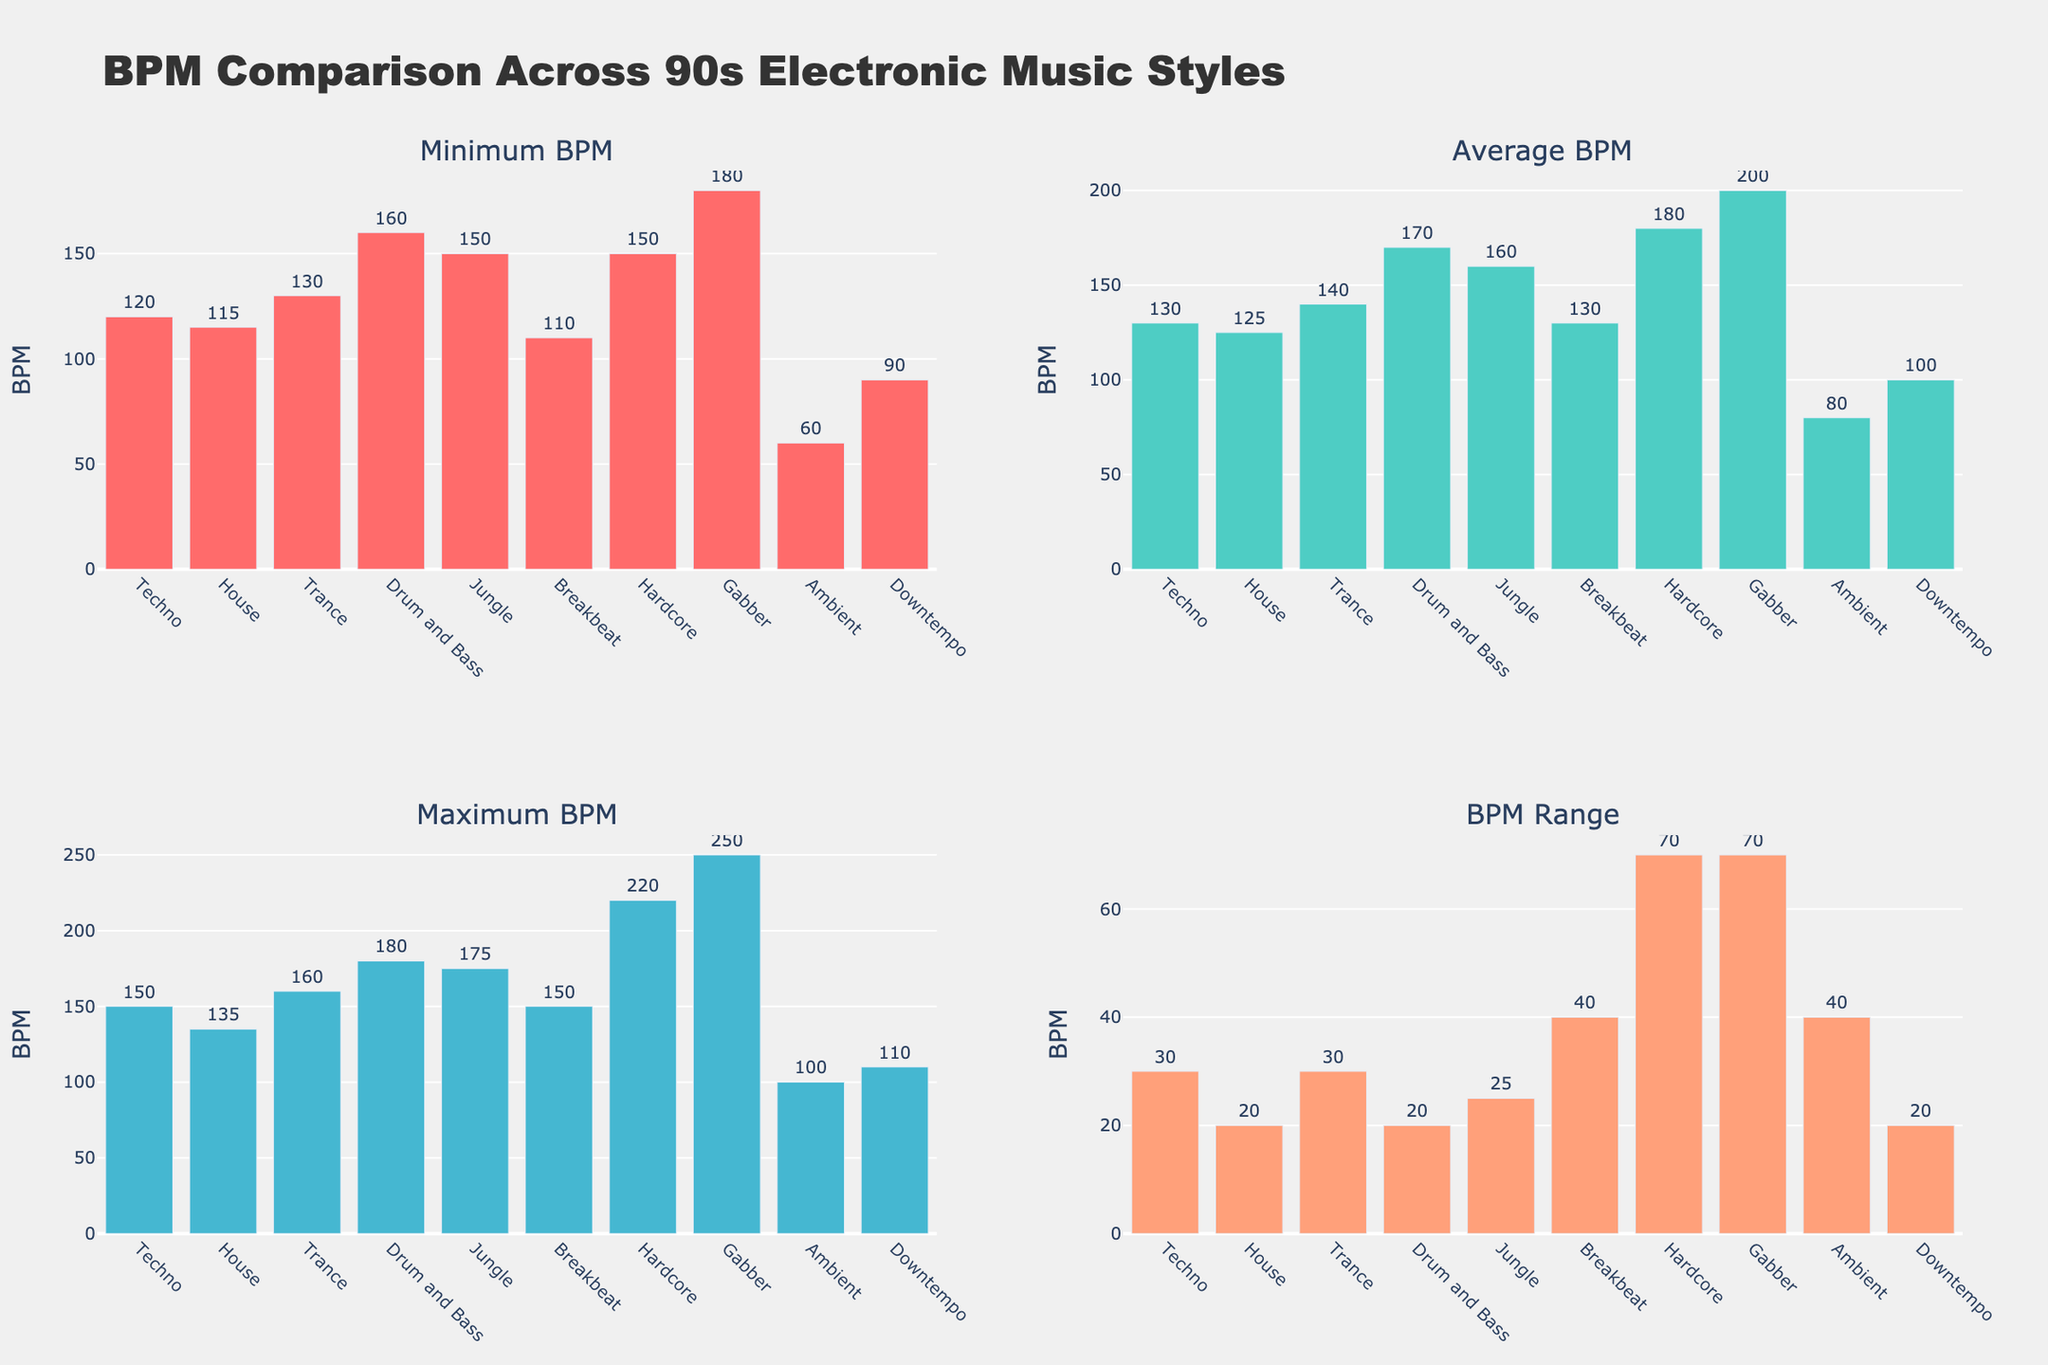How many electronic music styles are compared in the figure? Based on the x-axis labels in each subplot, there are 10 different electronic music styles listed.
Answer: 10 Which style has the lowest minimum BPM? By looking at the "Minimum BPM" subplot, Ambient has the lowest minimum BPM.
Answer: Ambient What is the range of BPM for Gabber? The "BPM Range" subplot shows the difference between Maximum BPM and Minimum BPM for Gabber. This range is 250 - 180 = 70 BPM.
Answer: 70 BPM Which style has the highest average BPM? By examining the "Average BPM" subplot, Gabber has the highest average BPM, which is 200.
Answer: Gabber Which styles share the same minimum BPM of 150? In the "Minimum BPM" subplot, both Jungle and Hardcore have a minimum BPM of 150.
Answer: Jungle and Hardcore What is the overall trend in the maximum BPM across the different styles? Observing the "Maximum BPM" subplot, the maximum BPM generally increases from Ambient/Downtempo to Gabber, with some variability among the styles.
Answer: Increases How does the BPM range of Drum and Bass compare to that of House? The "BPM Range" subplot shows that Drum and Bass has a range of 20 BPM (180 - 160), while House has a range of 20 BPM (135 - 115). Thus, their BPM ranges are equal.
Answer: Equal What is the difference in average BPM between Trance and House? The average BPM for Trance is 140 and for House is 125. So, the difference is 140 - 125 = 15 BPM.
Answer: 15 BPM In which subplot do we see Gabber having the highest value, and what is that value? Gabber has the highest value in the "Maximum BPM" subplot, where the value is 250 BPM.
Answer: Maximum BPM, 250 BPM Which styles fall under the category of having a maximum BPM of above 200? In the "Maximum BPM" subplot, Gabber (250 BPM) and Hardcore (220 BPM) have maximum BPMs above 200.
Answer: Gabber and Hardcore 